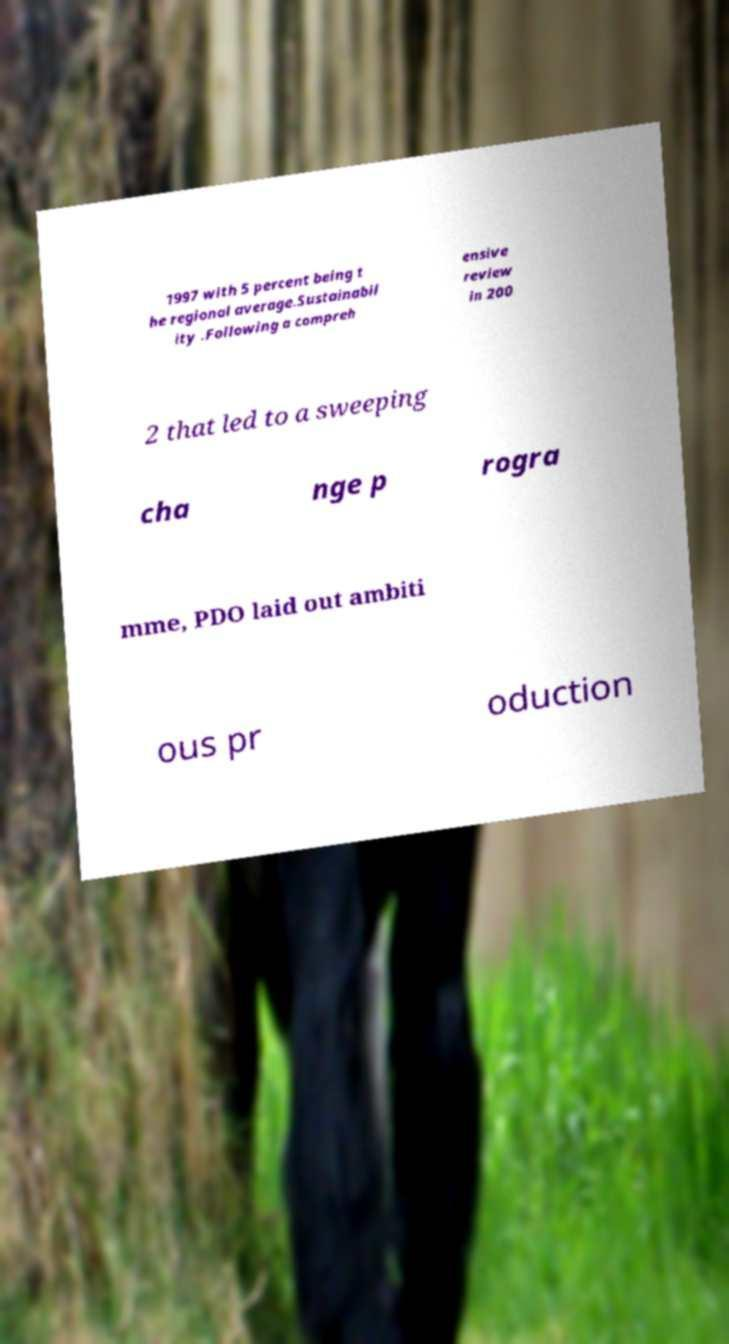There's text embedded in this image that I need extracted. Can you transcribe it verbatim? 1997 with 5 percent being t he regional average.Sustainabil ity .Following a compreh ensive review in 200 2 that led to a sweeping cha nge p rogra mme, PDO laid out ambiti ous pr oduction 